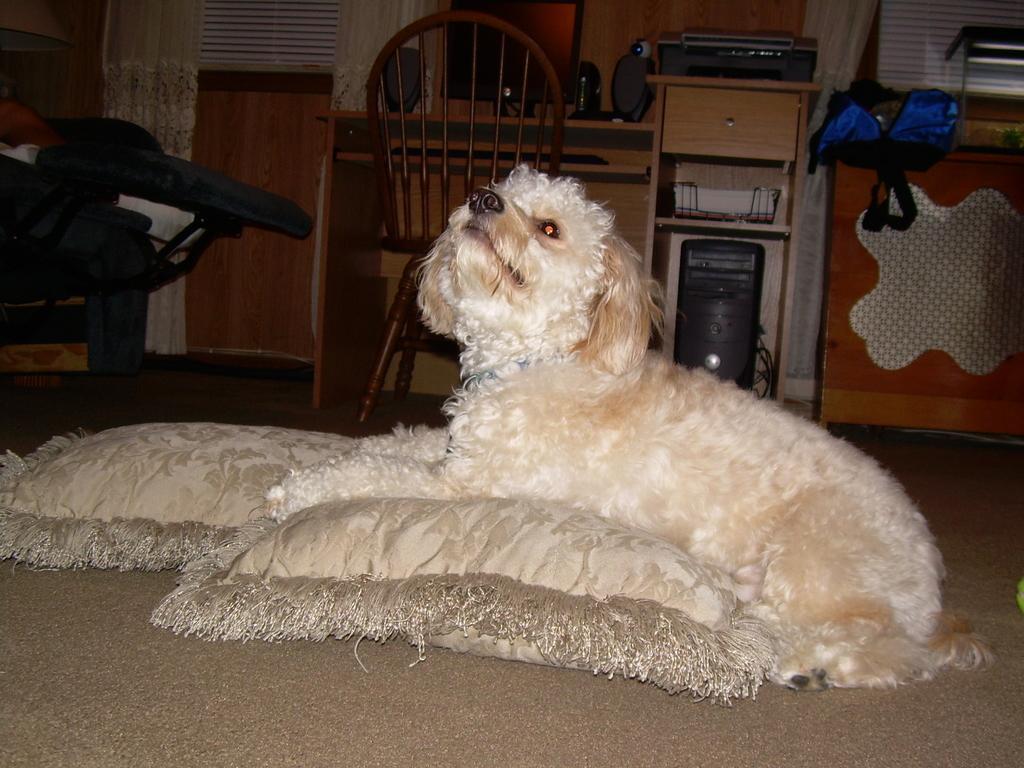Can you describe this image briefly? There is a dog sitting on a pillow and there is a desktop,chair and a table beside the dog. 